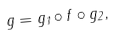<formula> <loc_0><loc_0><loc_500><loc_500>g = g _ { 1 } \circ f \circ g _ { 2 } ,</formula> 